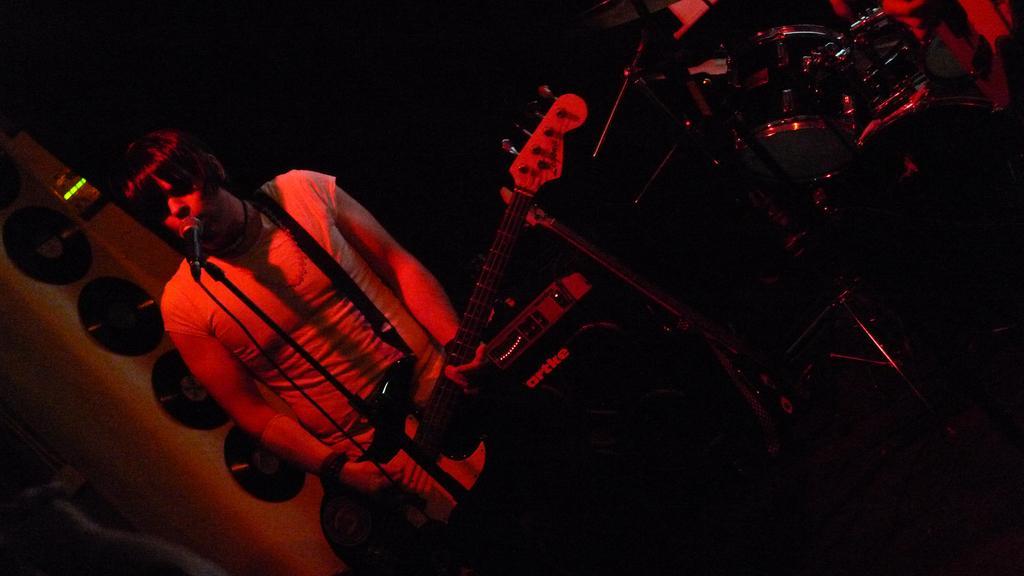In one or two sentences, can you explain what this image depicts? In the foreground of this image, there are musical instruments and mic stands and also a person holding a guitar in front of a mic. In the dark background, there is a red light and it seems like CD's on the wall. 